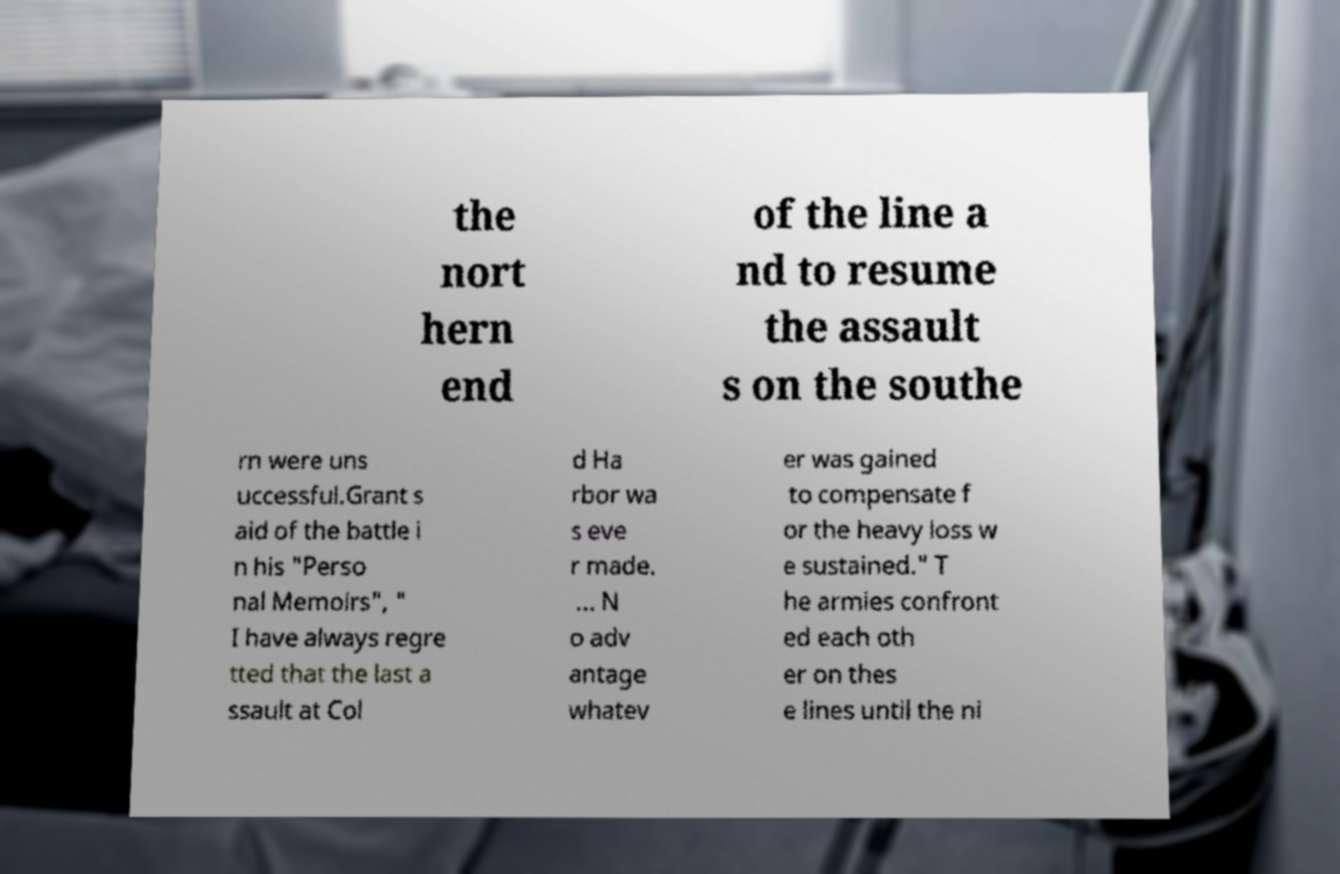There's text embedded in this image that I need extracted. Can you transcribe it verbatim? the nort hern end of the line a nd to resume the assault s on the southe rn were uns uccessful.Grant s aid of the battle i n his "Perso nal Memoirs", " I have always regre tted that the last a ssault at Col d Ha rbor wa s eve r made. ... N o adv antage whatev er was gained to compensate f or the heavy loss w e sustained." T he armies confront ed each oth er on thes e lines until the ni 